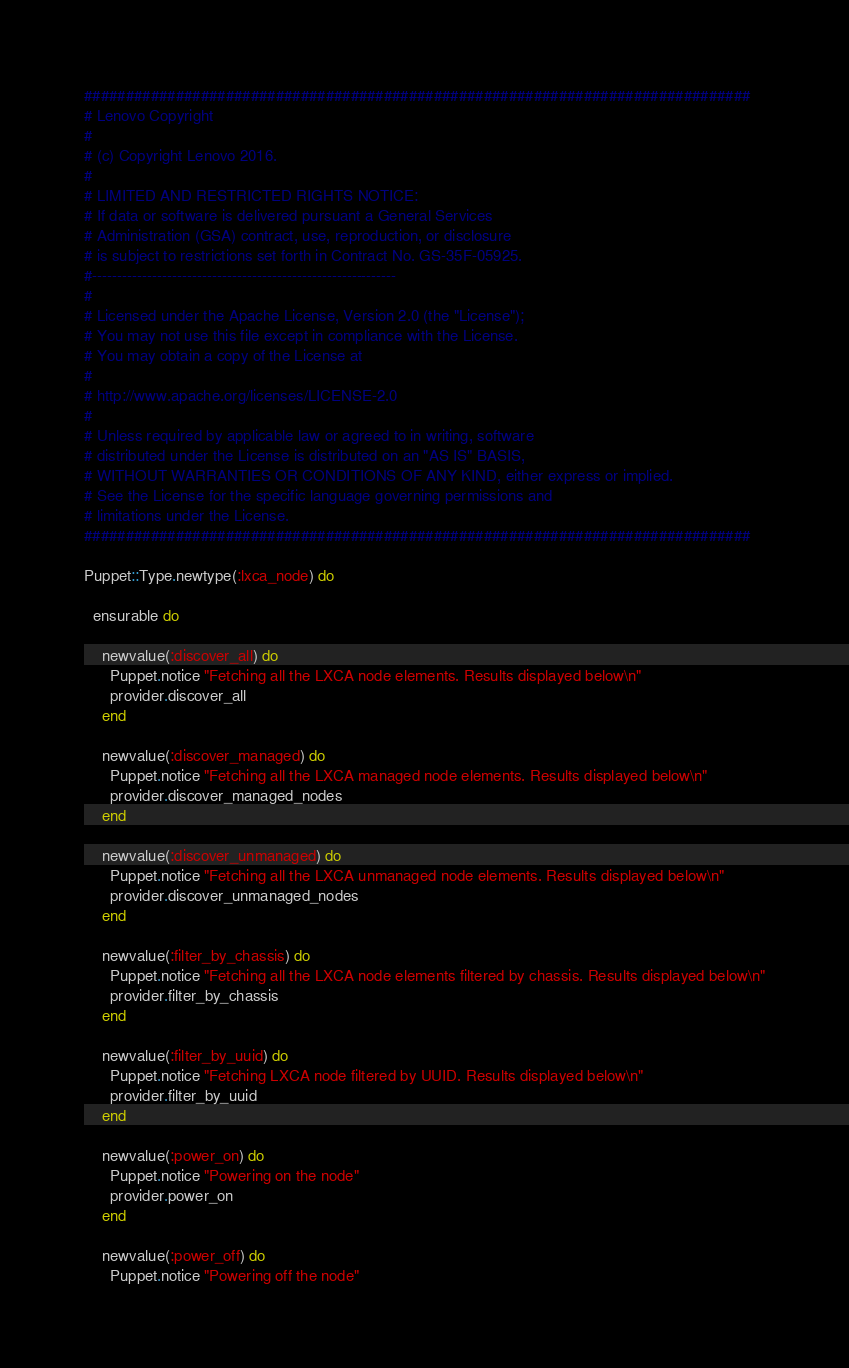Convert code to text. <code><loc_0><loc_0><loc_500><loc_500><_Ruby_>################################################################################
# Lenovo Copyright
#
# (c) Copyright Lenovo 2016.
#
# LIMITED AND RESTRICTED RIGHTS NOTICE:
# If data or software is delivered pursuant a General Services
# Administration (GSA) contract, use, reproduction, or disclosure
# is subject to restrictions set forth in Contract No. GS-35F-05925.
#-------------------------------------------------------------
#
# Licensed under the Apache License, Version 2.0 (the "License");
# You may not use this file except in compliance with the License.
# You may obtain a copy of the License at
#
# http://www.apache.org/licenses/LICENSE-2.0
#
# Unless required by applicable law or agreed to in writing, software
# distributed under the License is distributed on an "AS IS" BASIS,
# WITHOUT WARRANTIES OR CONDITIONS OF ANY KIND, either express or implied.
# See the License for the specific language governing permissions and
# limitations under the License.
################################################################################

Puppet::Type.newtype(:lxca_node) do

  ensurable do
    
    newvalue(:discover_all) do
      Puppet.notice "Fetching all the LXCA node elements. Results displayed below\n"
      provider.discover_all
    end

    newvalue(:discover_managed) do
      Puppet.notice "Fetching all the LXCA managed node elements. Results displayed below\n"
      provider.discover_managed_nodes
    end

    newvalue(:discover_unmanaged) do
      Puppet.notice "Fetching all the LXCA unmanaged node elements. Results displayed below\n"
      provider.discover_unmanaged_nodes
    end
 
    newvalue(:filter_by_chassis) do
      Puppet.notice "Fetching all the LXCA node elements filtered by chassis. Results displayed below\n"
      provider.filter_by_chassis
    end
    
    newvalue(:filter_by_uuid) do
      Puppet.notice "Fetching LXCA node filtered by UUID. Results displayed below\n"
      provider.filter_by_uuid
    end
    
    newvalue(:power_on) do
      Puppet.notice "Powering on the node"
      provider.power_on
    end

    newvalue(:power_off) do
      Puppet.notice "Powering off the node"</code> 